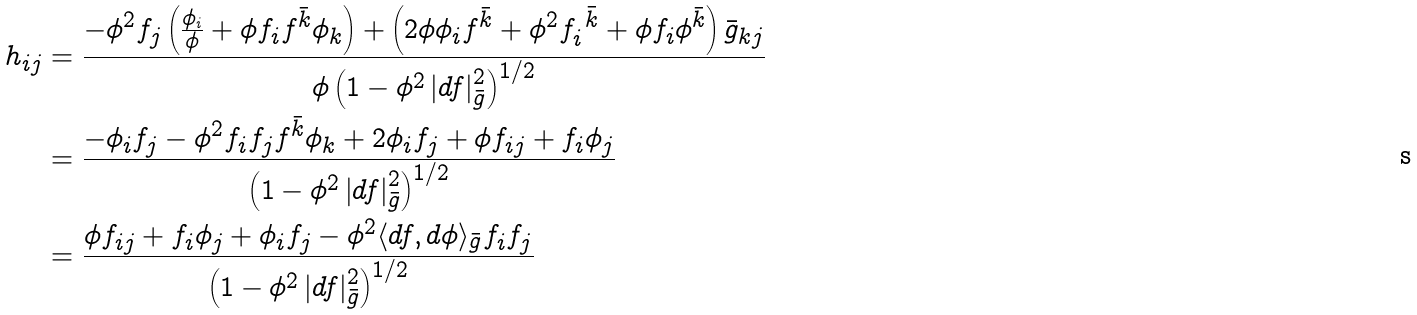<formula> <loc_0><loc_0><loc_500><loc_500>h _ { i j } & = \frac { - \phi ^ { 2 } f _ { j } \left ( \frac { \phi _ { i } } { \phi } + \phi f _ { i } f ^ { \bar { k } } \phi _ { k } \right ) + \left ( 2 \phi \phi _ { i } f ^ { \bar { k } } + \phi ^ { 2 } f _ { i } ^ { \ \bar { k } } + \phi f _ { i } \phi ^ { \bar { k } } \right ) \bar { g } _ { k j } } { \phi \left ( 1 - \phi ^ { 2 } \left | d f \right | ^ { 2 } _ { \bar { g } } \right ) ^ { 1 / 2 } } \\ & = \frac { - \phi _ { i } f _ { j } - \phi ^ { 2 } f _ { i } f _ { j } f ^ { \bar { k } } \phi _ { k } + 2 \phi _ { i } f _ { j } + \phi f _ { i j } + f _ { i } \phi _ { j } } { \left ( 1 - \phi ^ { 2 } \left | d f \right | ^ { 2 } _ { \bar { g } } \right ) ^ { 1 / 2 } } \\ & = \frac { \phi f _ { i j } + f _ { i } \phi _ { j } + \phi _ { i } f _ { j } - \phi ^ { 2 } \langle d f , d \phi \rangle _ { \bar { g } } f _ { i } f _ { j } } { \left ( 1 - \phi ^ { 2 } \left | d f \right | ^ { 2 } _ { \bar { g } } \right ) ^ { 1 / 2 } }</formula> 